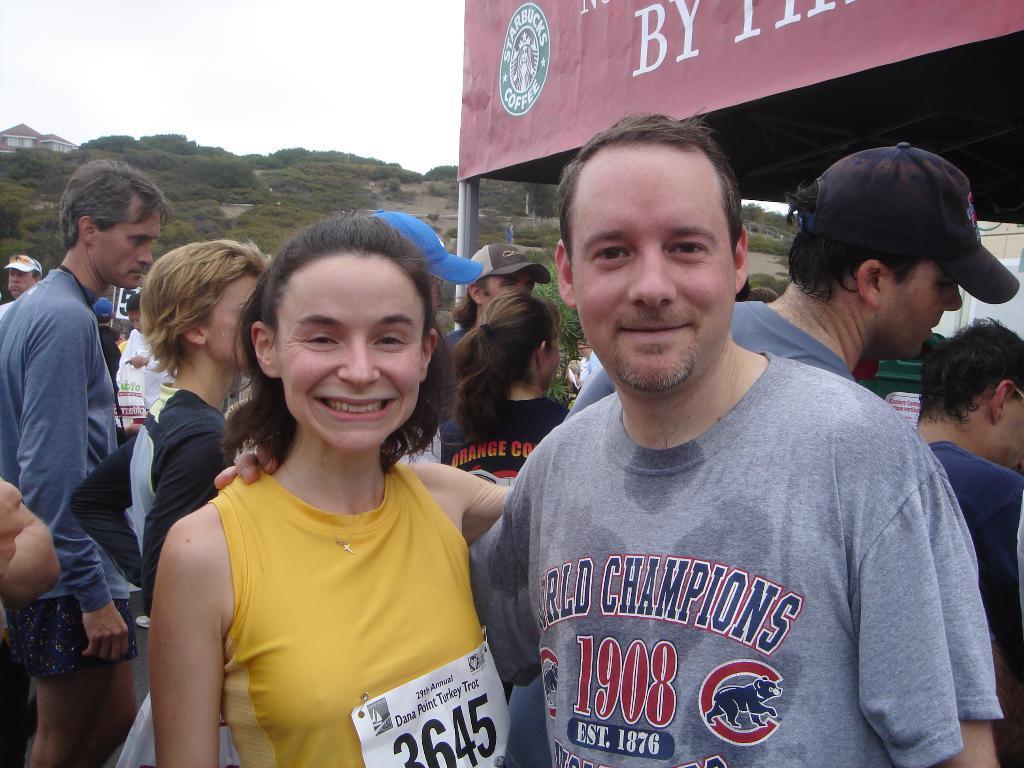Could you give a brief overview of what you see in this image? In this image there are two persons standing and smiling, and in the background there are group of people standing, stall with a name board , house, trees,sky. 